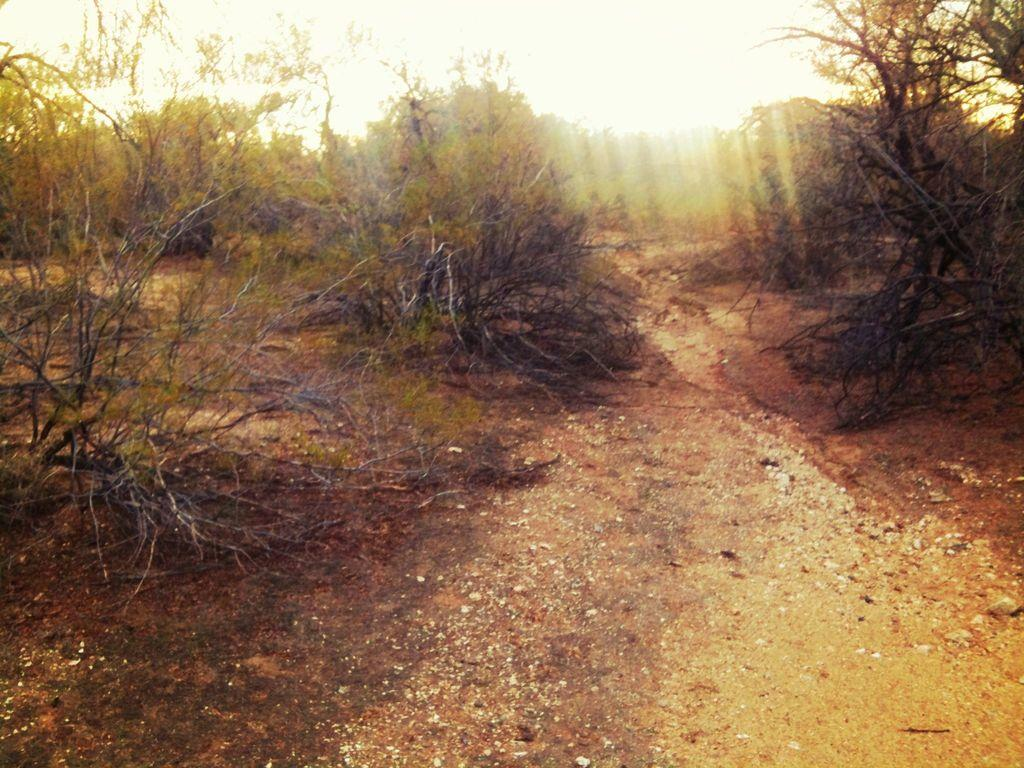What type of vegetation can be seen in the image? There are trees in the image. How would you describe the background of the image? The background of the image is blurred. What type of jam is being spread during the fight in the image? There is no jam or fight present in the image; it only features trees and a blurred background. 